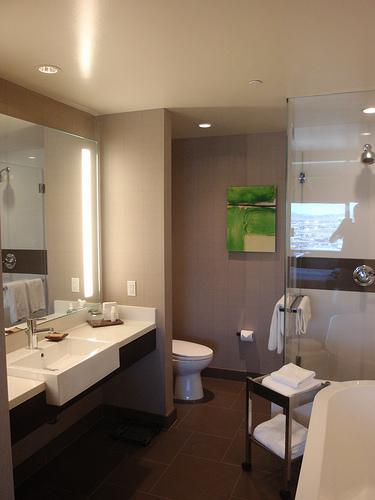Question: where is the toilet?
Choices:
A. The bathroom.
B. Next to the bathtub.
C. Near the shower.
D. Next to the far wall.
Answer with the letter. Answer: D Question: what color are the lights?
Choices:
A. Red.
B. Green.
C. Blue.
D. Yellow.
Answer with the letter. Answer: D Question: where was the picture taken?
Choices:
A. In a den.
B. In a bathroom.
C. In a kitchen.
D. In a bedroom.
Answer with the letter. Answer: B Question: what color is the floor?
Choices:
A. Yellow.
B. Brown.
C. Tan.
D. Gray.
Answer with the letter. Answer: B 